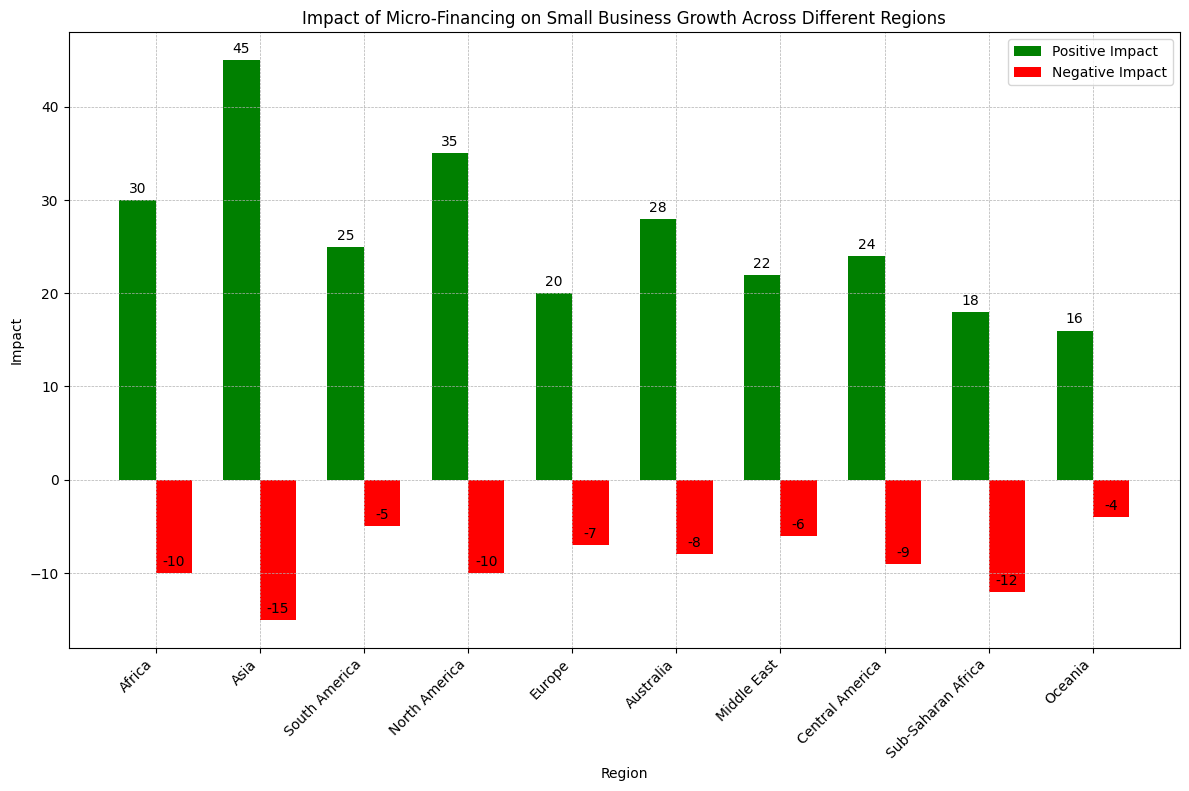Which region has the highest positive impact from micro-financing? The bar representing Asia is the tallest among the green bars, indicating it has the highest positive impact.
Answer: Asia Compare the negative impacts of Oceania and North America. Which is more severe? The negative impact bar for North America is lower (more negative) than the bar for Oceania, indicating a more severe negative impact.
Answer: North America What is the total positive impact across Europe and Africa? Europe has a positive impact of 20 and Africa has 30. Summing them up, 20 + 30 = 50.
Answer: 50 Between Australia and South America, which region shows a smaller negative impact? Australia's negative impact is -8, while South America's is -5; -5 is less negative than -8, so South America has the smaller negative impact.
Answer: South America What is the difference in positive impact between the Middle East and Central America? The positive impact for the Middle East is 22 and for Central America is 24. The difference is 24 - 22 = 2.
Answer: 2 How much greater is the positive impact in Asia compared to Europe? Asia's positive impact is 45, and Europe's is 20. The difference is 45 - 20 = 25.
Answer: 25 Which region has the smallest positive impact of micro-financing? The bar for Oceania is the shortest among the green bars, indicating the smallest positive impact.
Answer: Oceania What is the combined negative impact of Sub-Saharan Africa and Europe? Sub-Saharan Africa has a negative impact of -12, and Europe has -7. Combined, it is -12 + -7 = -19.
Answer: -19 Compare the positive and negative impacts within North America. Is the net impact positive or negative? The positive impact in North America is 35, and the negative impact is -10. Adding them, 35 + -10 = 25, showing a positive net impact.
Answer: Positive Which region has an equal magnitude of negative and positive impacts? Sub-Saharan Africa has a positive impact of 18 and a negative impact of -12, and no region has equal magnitude for both impacts.
Answer: None 